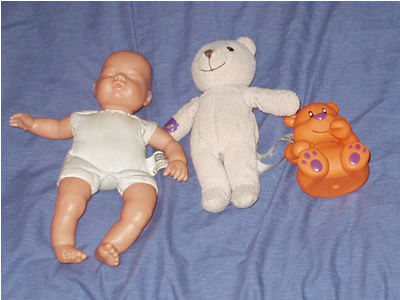<image>Does the baby doll have eyes? I am uncertain if the baby doll has eyes. Does the baby doll have eyes? The baby doll does not have eyes. 